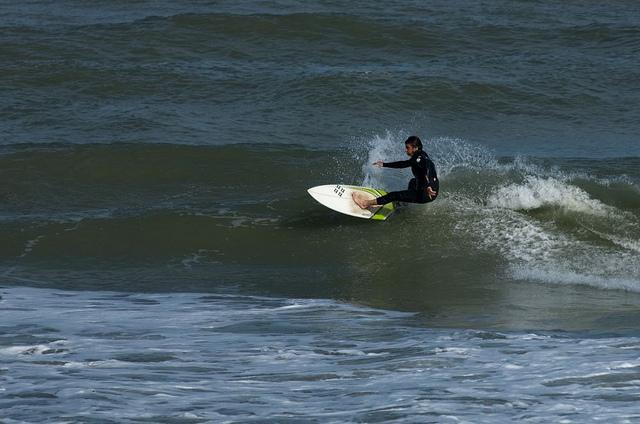What color is the surfboard?
Give a very brief answer. White. Is he turning?
Give a very brief answer. Yes. Is this person surfing?
Write a very short answer. Yes. 